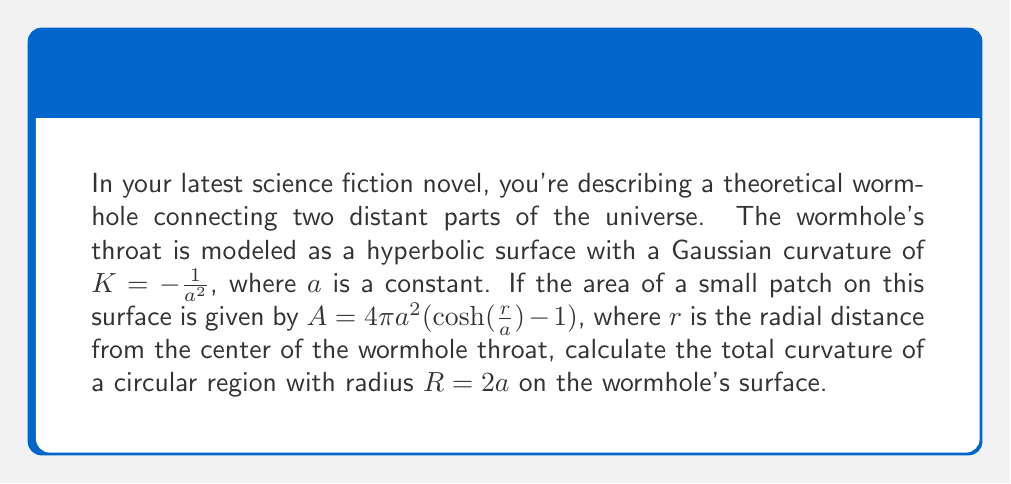Solve this math problem. To solve this problem, we'll follow these steps:

1) The total curvature of a region is given by the integral of the Gaussian curvature over the area:

   $$\int\int K dA$$

2) We're given that $K = -\frac{1}{a^2}$, which is constant over the surface.

3) The area element $dA$ can be found by differentiating the given area formula with respect to $r$:

   $$\frac{dA}{dr} = 4\pi a \sinh(\frac{r}{a})$$
   $$dA = 4\pi a \sinh(\frac{r}{a}) dr$$

4) Now we can set up our integral:

   $$\int\int K dA = \int_0^R K \cdot 4\pi a \sinh(\frac{r}{a}) dr$$

5) Substituting the values:

   $$\int_0^{2a} (-\frac{1}{a^2}) \cdot 4\pi a \sinh(\frac{r}{a}) dr$$

6) Simplifying:

   $$-4\pi \int_0^{2a} \frac{1}{a} \sinh(\frac{r}{a}) dr$$

7) Integrating:

   $$-4\pi [-\cosh(\frac{r}{a})]_0^{2a}$$

8) Evaluating the limits:

   $$-4\pi [-\cosh(2) + \cosh(0)]$$
   $$-4\pi [-\cosh(2) + 1]$$

9) The value of $\cosh(2)$ is approximately 3.7622, so:

   $$-4\pi [- 3.7622 + 1]$$
   $$-4\pi [-2.7622]$$
   $$11.0488\pi$$

Thus, the total curvature of the circular region is $11.0488\pi$.
Answer: $11.0488\pi$ 